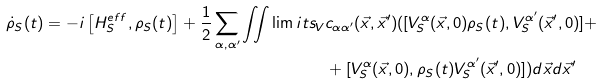<formula> <loc_0><loc_0><loc_500><loc_500>\dot { \rho } _ { S } ( t ) = - i \left [ H _ { S } ^ { e f f } , \rho _ { S } ( t ) \right ] + \frac { 1 } { 2 } \sum _ { \alpha , \alpha ^ { \prime } } \iint \lim i t s _ { V } & c _ { \alpha \alpha ^ { \prime } } ( \vec { x } , \vec { x } ^ { \prime } ) ( [ V _ { S } ^ { \alpha } ( \vec { x } , 0 ) \rho _ { S } ( t ) , V _ { S } ^ { \alpha ^ { \prime } } ( \vec { x } ^ { \prime } , 0 ) ] + \\ & + [ V _ { S } ^ { \alpha } ( \vec { x } , 0 ) , \rho _ { S } ( t ) V _ { S } ^ { \alpha ^ { \prime } } ( \vec { x } ^ { \prime } , 0 ) ] ) d \vec { x } d \vec { x } ^ { \prime }</formula> 